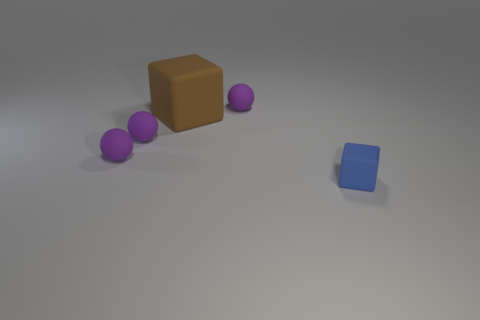There is another object that is the same shape as the big brown object; what color is it?
Provide a short and direct response. Blue. What number of things are green cylinders or rubber cubes?
Your answer should be very brief. 2. There is a large brown thing that is the same material as the tiny blue thing; what is its shape?
Your answer should be very brief. Cube. What number of big things are red matte cylinders or brown blocks?
Provide a succinct answer. 1. There is a block that is on the right side of the matte cube that is to the left of the blue thing; how many brown things are right of it?
Keep it short and to the point. 0. Does the matte thing that is behind the brown block have the same size as the blue rubber block?
Make the answer very short. Yes. Is the number of small purple spheres in front of the tiny block less than the number of small purple matte balls that are behind the large matte cube?
Provide a succinct answer. Yes. Is the number of big brown things that are to the right of the tiny blue matte thing less than the number of matte cylinders?
Ensure brevity in your answer.  No. How many other blue cubes have the same material as the blue cube?
Provide a short and direct response. 0. There is a tiny block that is made of the same material as the big brown object; what is its color?
Keep it short and to the point. Blue. 